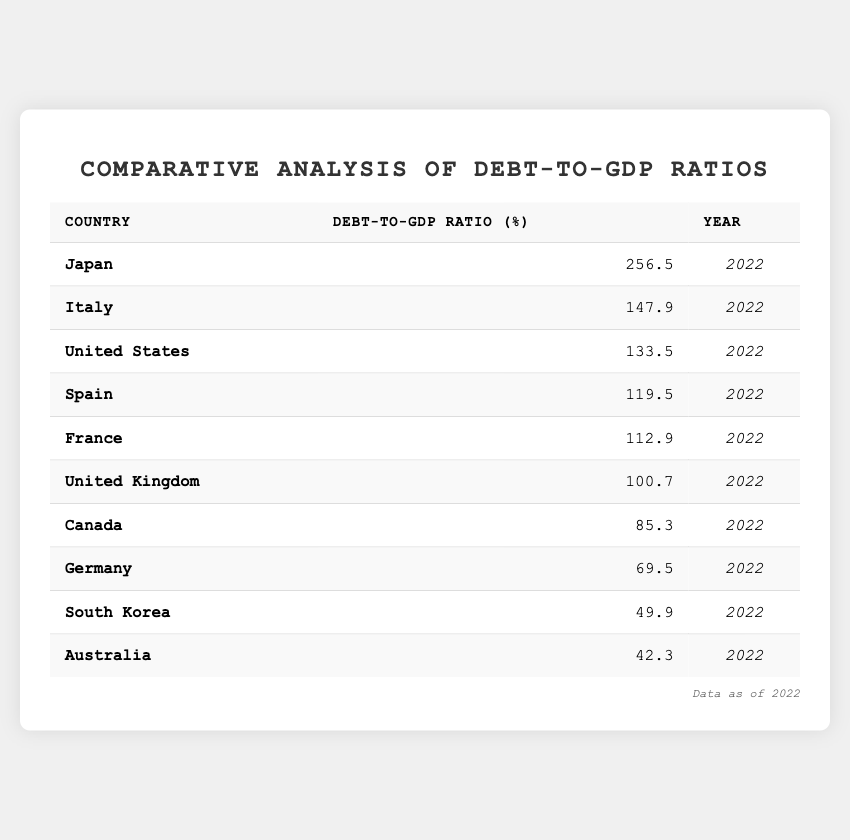What is the debt-to-GDP ratio of Japan? The table lists Japan's debt-to-GDP ratio as 256.5% for the year 2022 directly.
Answer: 256.5% Which country has the lowest debt-to-GDP ratio? By examining the entries, Australia has the lowest ratio at 42.3% among all the countries listed.
Answer: Australia What is the debt-to-GDP ratio of Canada compared to Germany? Canada has a debt-to-GDP ratio of 85.3%, while Germany's is 69.5%. Subtracting these, Canada has a higher ratio by 15.8%.
Answer: 15.8% higher What is the average debt-to-GDP ratio of the top three countries? The top three countries by debt-to-GDP ratio are Japan (256.5%), Italy (147.9%), and the USA (133.5%). Summing these gives 637.9%, and dividing by 3 gives an average of 212.63%.
Answer: 212.63% Is the debt-to-GDP ratio of France higher than that of the United Kingdom? France's ratio is 112.9% and the UK’s is 100.7%. Since 112.9% is greater than 100.7%, this statement is true.
Answer: Yes What is the total debt-to-GDP ratio of the European countries listed? The European countries are Germany (69.5%), France (112.9%), Italy (147.9%), Spain (119.5%), and the United Kingdom (100.7%). Summing these gives 550.5%.
Answer: 550.5% Which countries have debt-to-GDP ratios below 100%? Looking at the table, the countries with ratios below 100% are South Korea (49.9%), Australia (42.3%), and Germany (69.5%).
Answer: South Korea, Australia, Germany How much greater is Japan's debt-to-GDP ratio compared to the global average from the table? First, the total number of countries is 10; summing all, we have 1336.3%. The average would be 1336.3/10 = 133.63%. Japan's ratio (256.5%) is 122.87% higher than the average (256.5 - 133.63).
Answer: 122.87% higher What percentage of the debt-to-GDP ratio does Italy have compared to Japan? Italy's ratio (147.9%) when compared to Japan's (256.5%) means (147.9/256.5) * 100 = approximately 57.69%.
Answer: 57.69% Which country has a debt-to-GDP ratio closer to the average of all countries listed? From the previous calculations, the average was approximately 133.63%. Looking through the list, the UK (100.7% is closest with only 32.93% lower than the average).
Answer: United Kingdom 